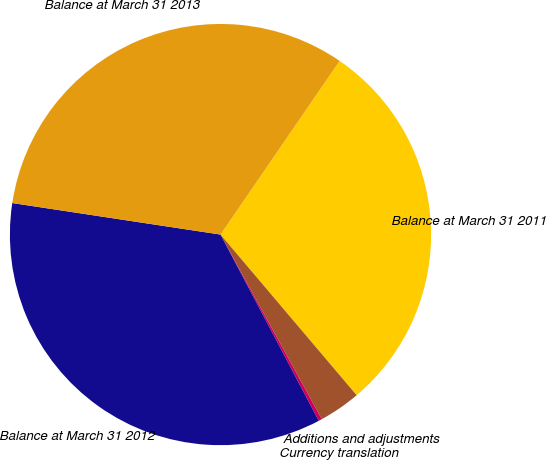Convert chart to OTSL. <chart><loc_0><loc_0><loc_500><loc_500><pie_chart><fcel>Balance at March 31 2011<fcel>Additions and adjustments<fcel>Currency translation<fcel>Balance at March 31 2012<fcel>Balance at March 31 2013<nl><fcel>29.24%<fcel>3.2%<fcel>0.26%<fcel>35.12%<fcel>32.18%<nl></chart> 